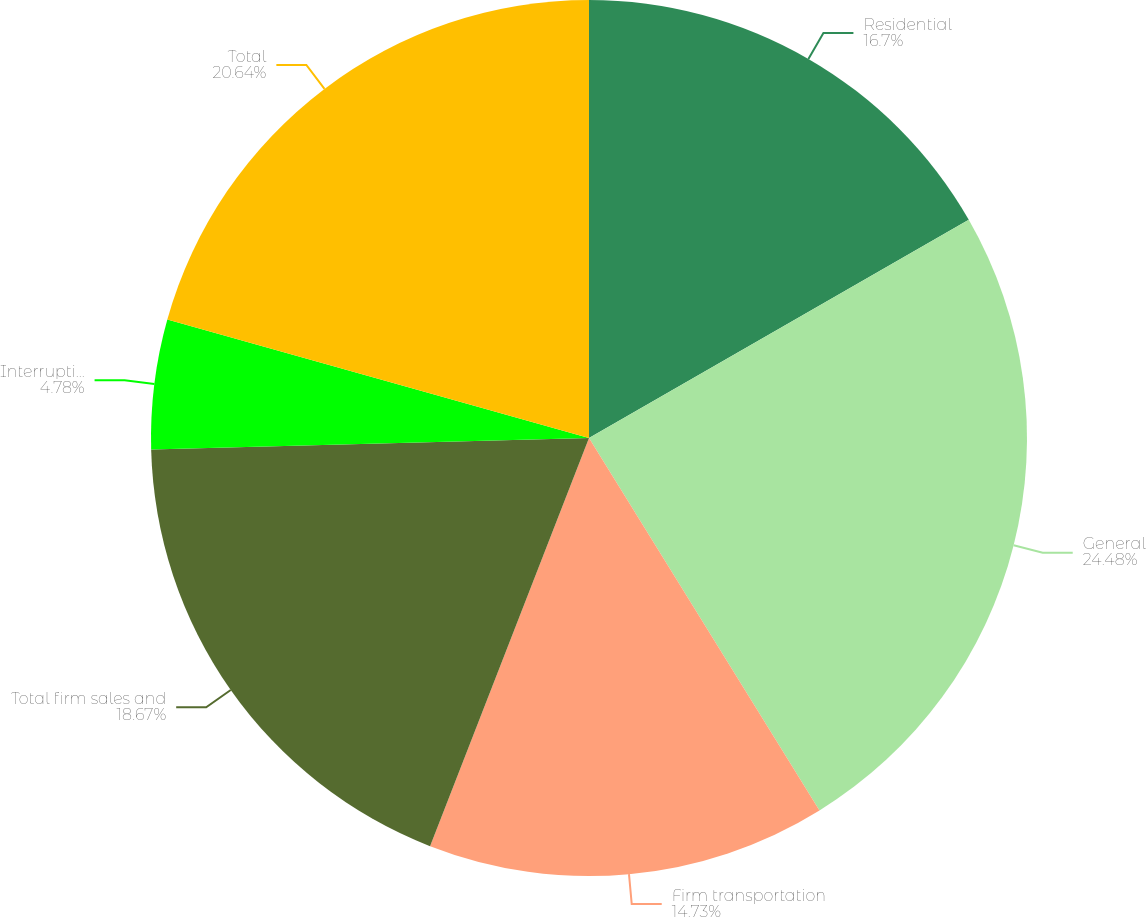Convert chart to OTSL. <chart><loc_0><loc_0><loc_500><loc_500><pie_chart><fcel>Residential<fcel>General<fcel>Firm transportation<fcel>Total firm sales and<fcel>Interruptible sales<fcel>Total<nl><fcel>16.7%<fcel>24.48%<fcel>14.73%<fcel>18.67%<fcel>4.78%<fcel>20.64%<nl></chart> 